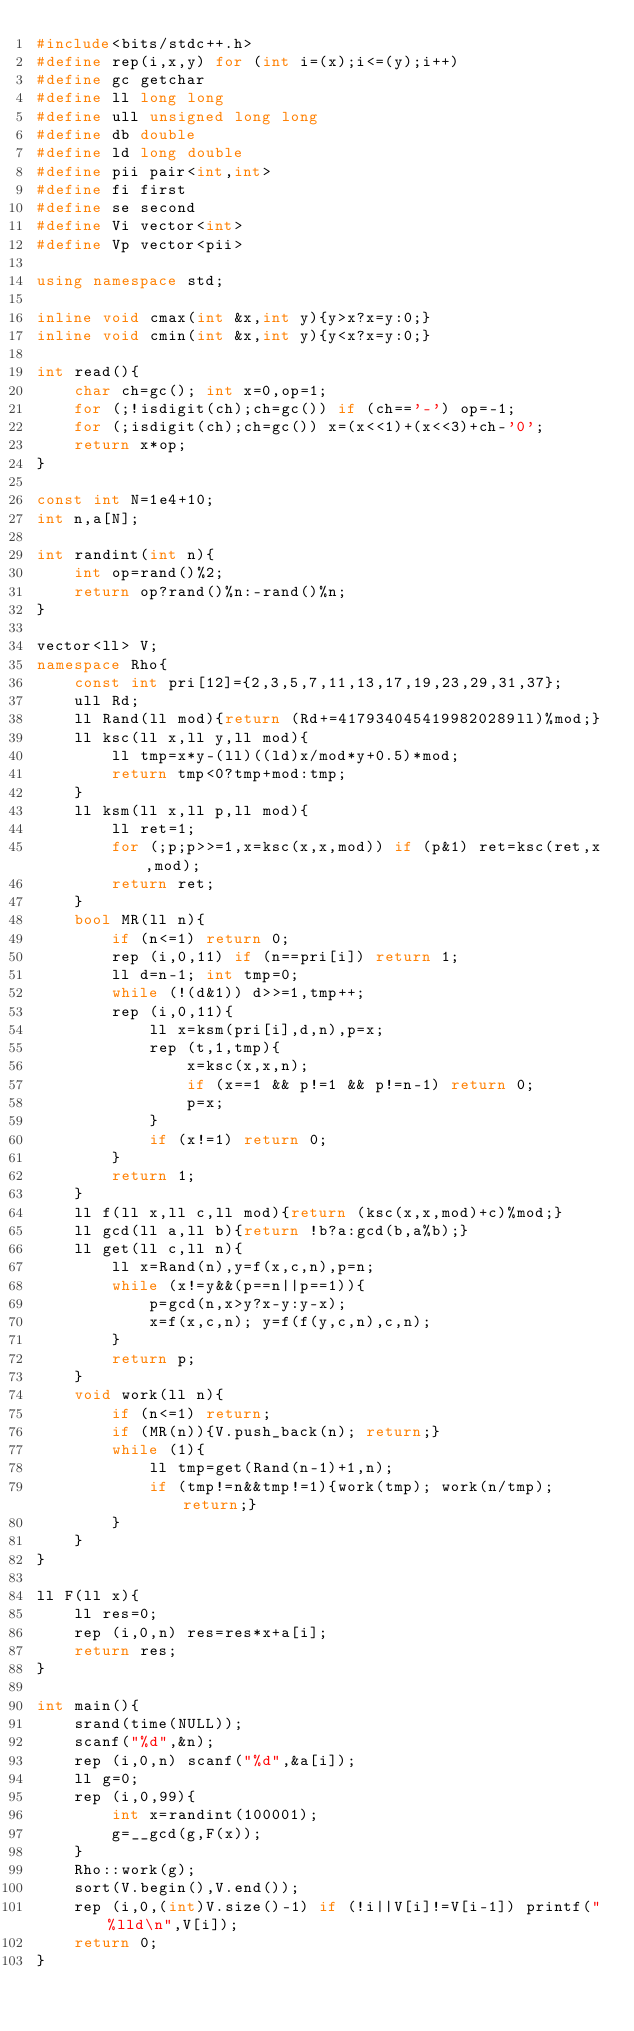<code> <loc_0><loc_0><loc_500><loc_500><_C++_>#include<bits/stdc++.h>
#define rep(i,x,y) for (int i=(x);i<=(y);i++)
#define gc getchar
#define ll long long
#define ull unsigned long long
#define db double
#define ld long double
#define pii pair<int,int>
#define fi first
#define se second
#define Vi vector<int>
#define Vp vector<pii>

using namespace std;

inline void cmax(int &x,int y){y>x?x=y:0;}
inline void cmin(int &x,int y){y<x?x=y:0;}

int read(){
	char ch=gc(); int x=0,op=1;
	for (;!isdigit(ch);ch=gc()) if (ch=='-') op=-1;
	for (;isdigit(ch);ch=gc()) x=(x<<1)+(x<<3)+ch-'0';
	return x*op;
}

const int N=1e4+10;
int n,a[N];

int randint(int n){
	int op=rand()%2;
	return op?rand()%n:-rand()%n;
}

vector<ll> V;
namespace Rho{
    const int pri[12]={2,3,5,7,11,13,17,19,23,29,31,37};
    ull Rd;
    ll Rand(ll mod){return (Rd+=4179340454199820289ll)%mod;}
    ll ksc(ll x,ll y,ll mod){
        ll tmp=x*y-(ll)((ld)x/mod*y+0.5)*mod;
        return tmp<0?tmp+mod:tmp;
    }
    ll ksm(ll x,ll p,ll mod){
        ll ret=1;
        for (;p;p>>=1,x=ksc(x,x,mod)) if (p&1) ret=ksc(ret,x,mod);
        return ret;
    }
    bool MR(ll n){
        if (n<=1) return 0;
        rep (i,0,11) if (n==pri[i]) return 1;
        ll d=n-1; int tmp=0;
        while (!(d&1)) d>>=1,tmp++;
        rep (i,0,11){
            ll x=ksm(pri[i],d,n),p=x;
            rep (t,1,tmp){
                x=ksc(x,x,n);
                if (x==1 && p!=1 && p!=n-1) return 0;
                p=x;
            }
            if (x!=1) return 0;
        }
        return 1;
    }
    ll f(ll x,ll c,ll mod){return (ksc(x,x,mod)+c)%mod;}
    ll gcd(ll a,ll b){return !b?a:gcd(b,a%b);}
    ll get(ll c,ll n){
        ll x=Rand(n),y=f(x,c,n),p=n;
        while (x!=y&&(p==n||p==1)){
            p=gcd(n,x>y?x-y:y-x);
            x=f(x,c,n); y=f(f(y,c,n),c,n);
        }
        return p;
    }
    void work(ll n){
        if (n<=1) return;
        if (MR(n)){V.push_back(n); return;}
        while (1){
            ll tmp=get(Rand(n-1)+1,n);
            if (tmp!=n&&tmp!=1){work(tmp); work(n/tmp); return;}
        }
    }
}

ll F(ll x){
	ll res=0;
	rep (i,0,n) res=res*x+a[i];
	return res;
}

int main(){
	srand(time(NULL));
	scanf("%d",&n);
	rep (i,0,n) scanf("%d",&a[i]);
	ll g=0;
	rep (i,0,99){
		int x=randint(100001);
		g=__gcd(g,F(x));
	}
	Rho::work(g);
	sort(V.begin(),V.end());
	rep (i,0,(int)V.size()-1) if (!i||V[i]!=V[i-1]) printf("%lld\n",V[i]);
	return 0;
}
</code> 